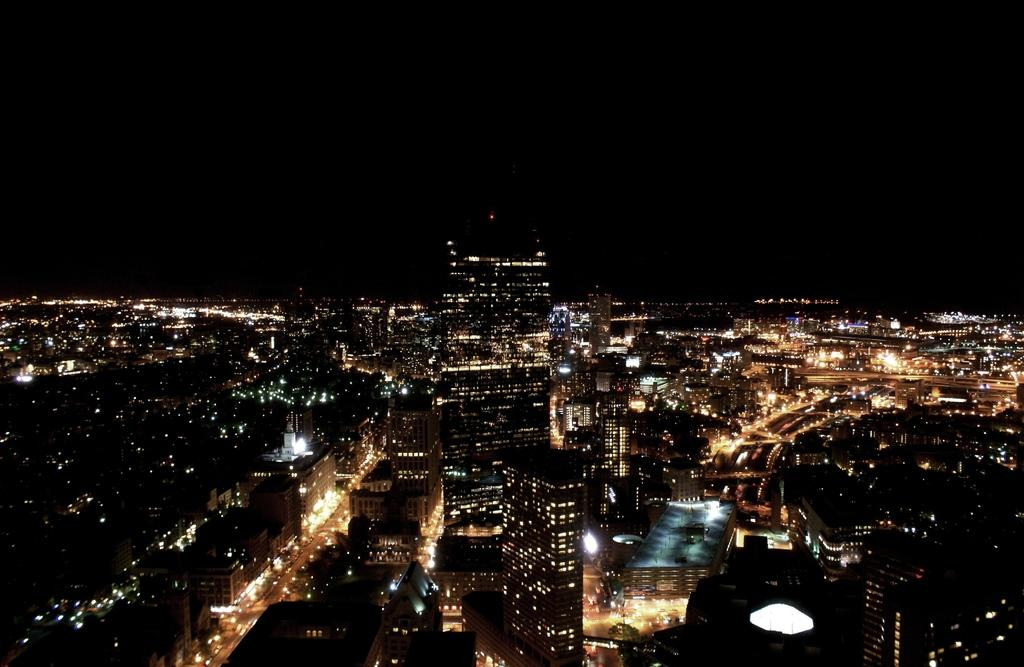What type of structures are visible in the image? There are buildings in the image. What can be seen illuminating the scene in the image? There are lights in the image. How would you describe the overall lighting in the image? The background of the image is dark. What type of oatmeal is being served at the club in the image? There is no oatmeal or club present in the image; it only features buildings and lights. What type of education is being offered at the location in the image? There is no indication of any educational institution or activity in the image. 